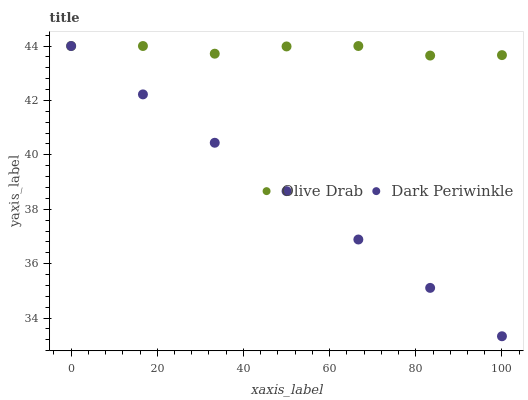Does Dark Periwinkle have the minimum area under the curve?
Answer yes or no. Yes. Does Olive Drab have the maximum area under the curve?
Answer yes or no. Yes. Does Olive Drab have the minimum area under the curve?
Answer yes or no. No. Is Dark Periwinkle the smoothest?
Answer yes or no. Yes. Is Olive Drab the roughest?
Answer yes or no. Yes. Is Olive Drab the smoothest?
Answer yes or no. No. Does Dark Periwinkle have the lowest value?
Answer yes or no. Yes. Does Olive Drab have the lowest value?
Answer yes or no. No. Does Olive Drab have the highest value?
Answer yes or no. Yes. Does Dark Periwinkle intersect Olive Drab?
Answer yes or no. Yes. Is Dark Periwinkle less than Olive Drab?
Answer yes or no. No. Is Dark Periwinkle greater than Olive Drab?
Answer yes or no. No. 